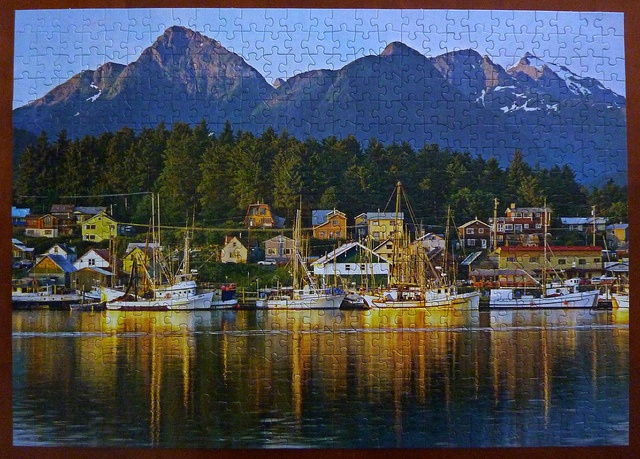Describe the objects in this image and their specific colors. I can see boat in maroon, black, olive, gray, and darkgray tones, boat in maroon, black, darkgray, gray, and olive tones, boat in maroon, darkgray, gray, and tan tones, boat in maroon, darkgray, gray, and black tones, and boat in maroon, darkgray, gray, and olive tones in this image. 